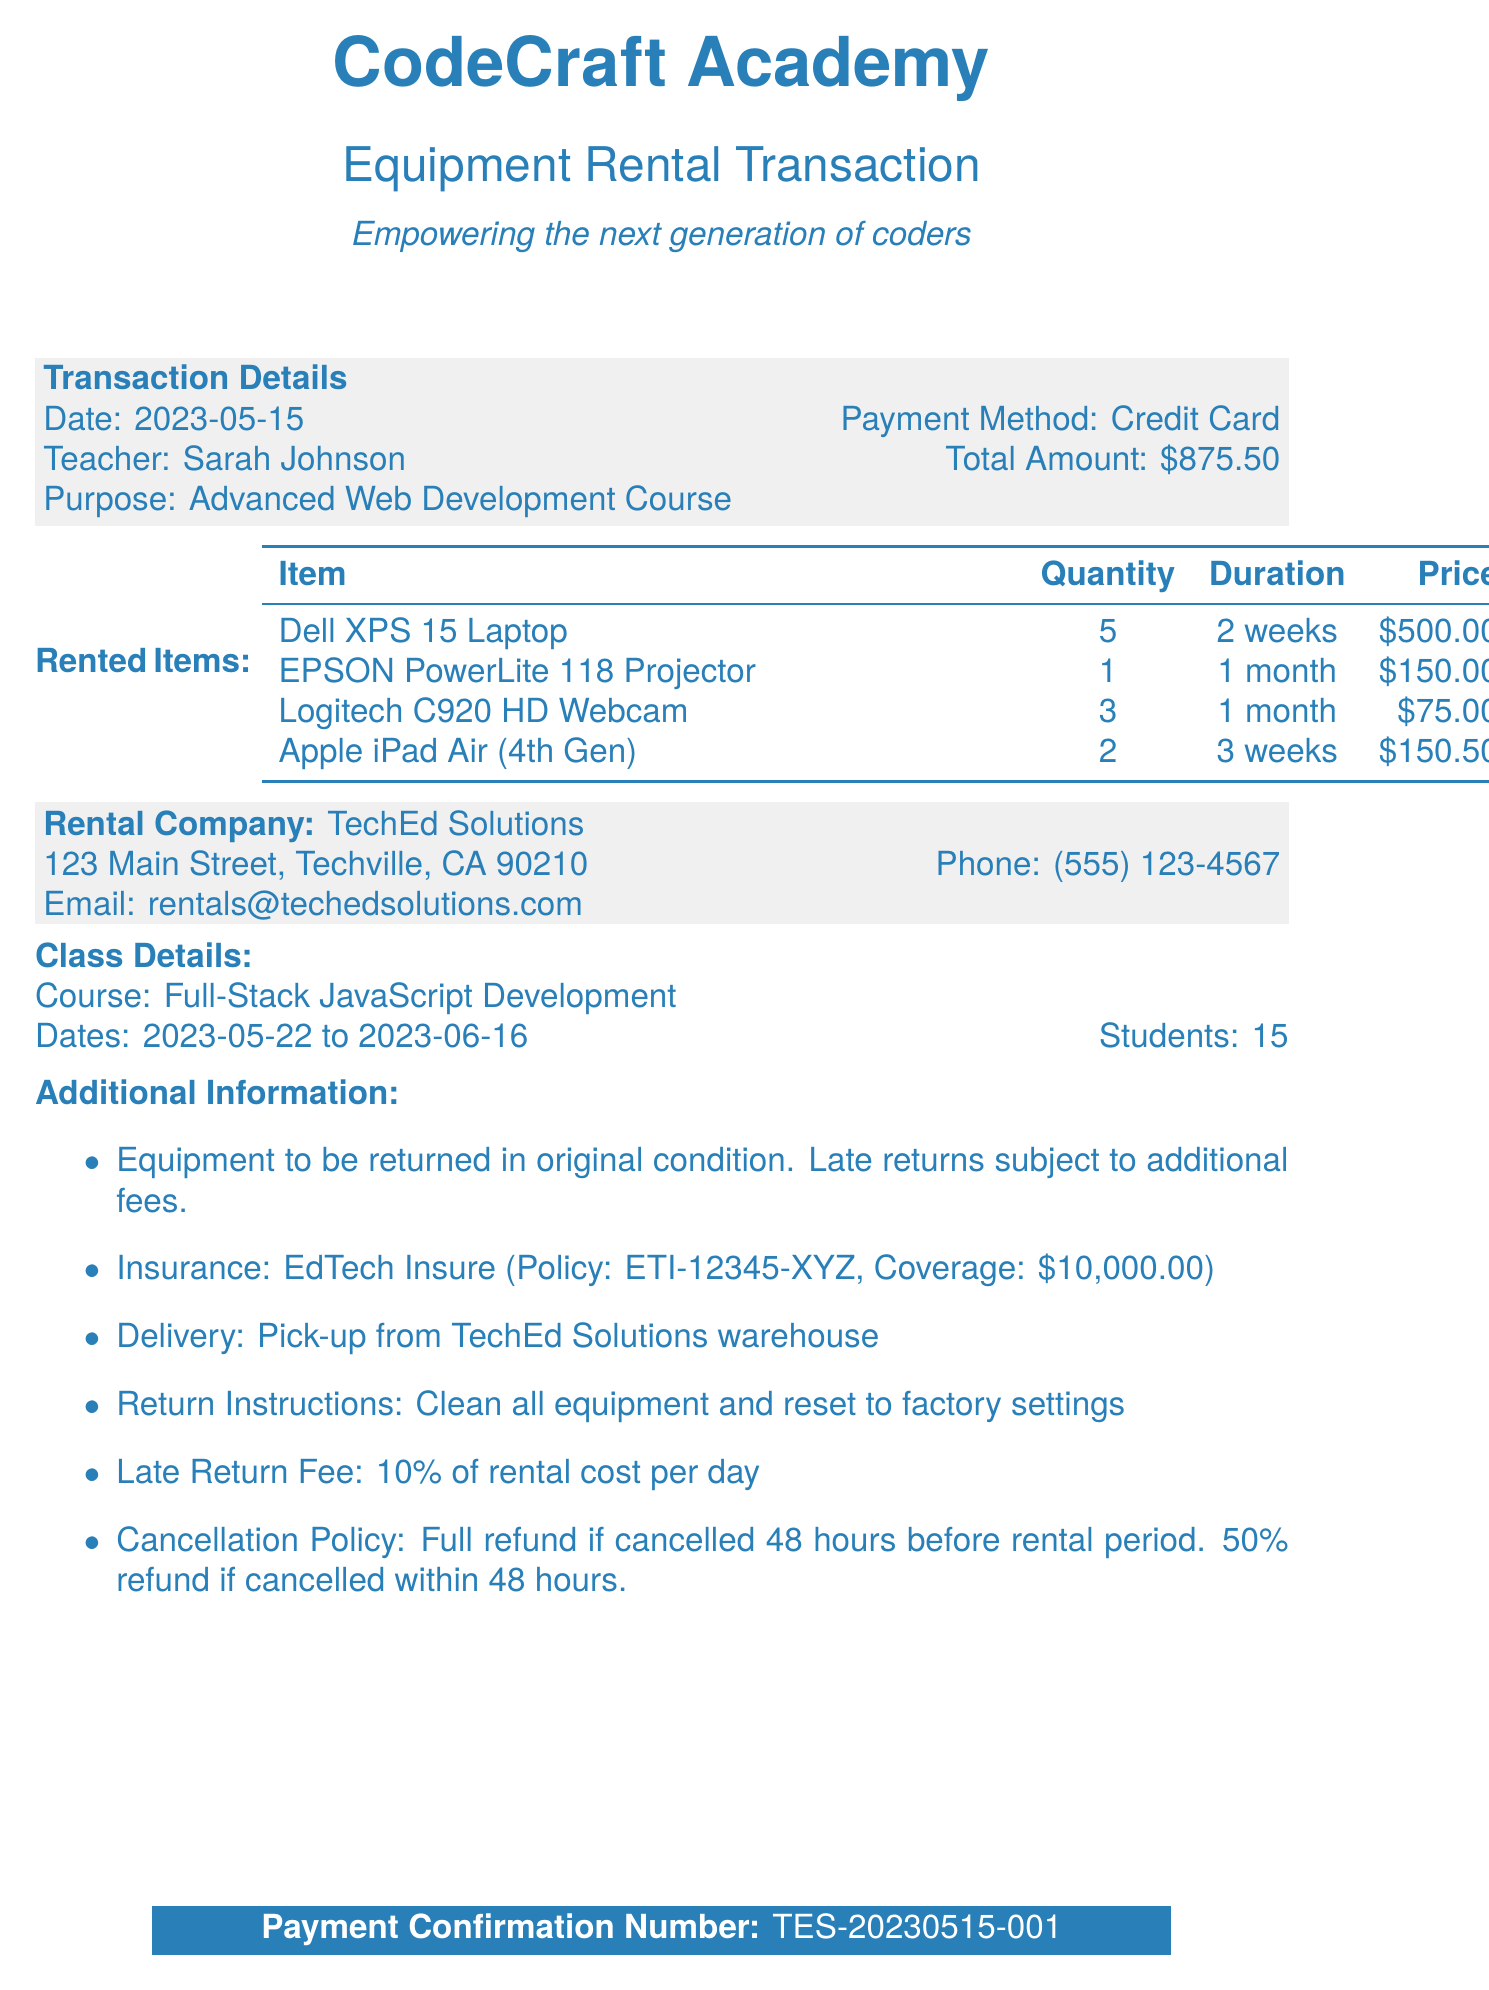What is the transaction date? The transaction date is clearly stated in the document as the day the transaction occurred.
Answer: 2023-05-15 Who is the teacher's name? The document mentions the teacher involved in this transaction.
Answer: Sarah Johnson What is the total amount? The total amount reflects the sum to be paid for the rented items and is specifically listed.
Answer: $875.50 How many Dell XPS 15 Laptops were rented? The quantity of each rented item is detailed, including the Dell XPS 15 Laptop.
Answer: 5 What is the duration for the EPSON PowerLite 118 Projector rental? The duration indicates how long the equipment will be rented for, which is specified in the document.
Answer: 1 month What is the late return fee percentage? This specific fee is highlighted in the document, denoting the cost for late returns.
Answer: 10% What is the cancellation policy? The policy outlines what happens if the rental is canceled and is explicitly stated in the document.
Answer: Full refund if cancelled 48 hours before rental period. 50% refund if cancelled within 48 hours Who is the insurance provider? The document provides details regarding the insurance related to the rental.
Answer: EdTech Insure What is the payment confirmation number? The confirmation number serves as a unique identifier for the transaction and is directly stated.
Answer: TES-20230515-001 